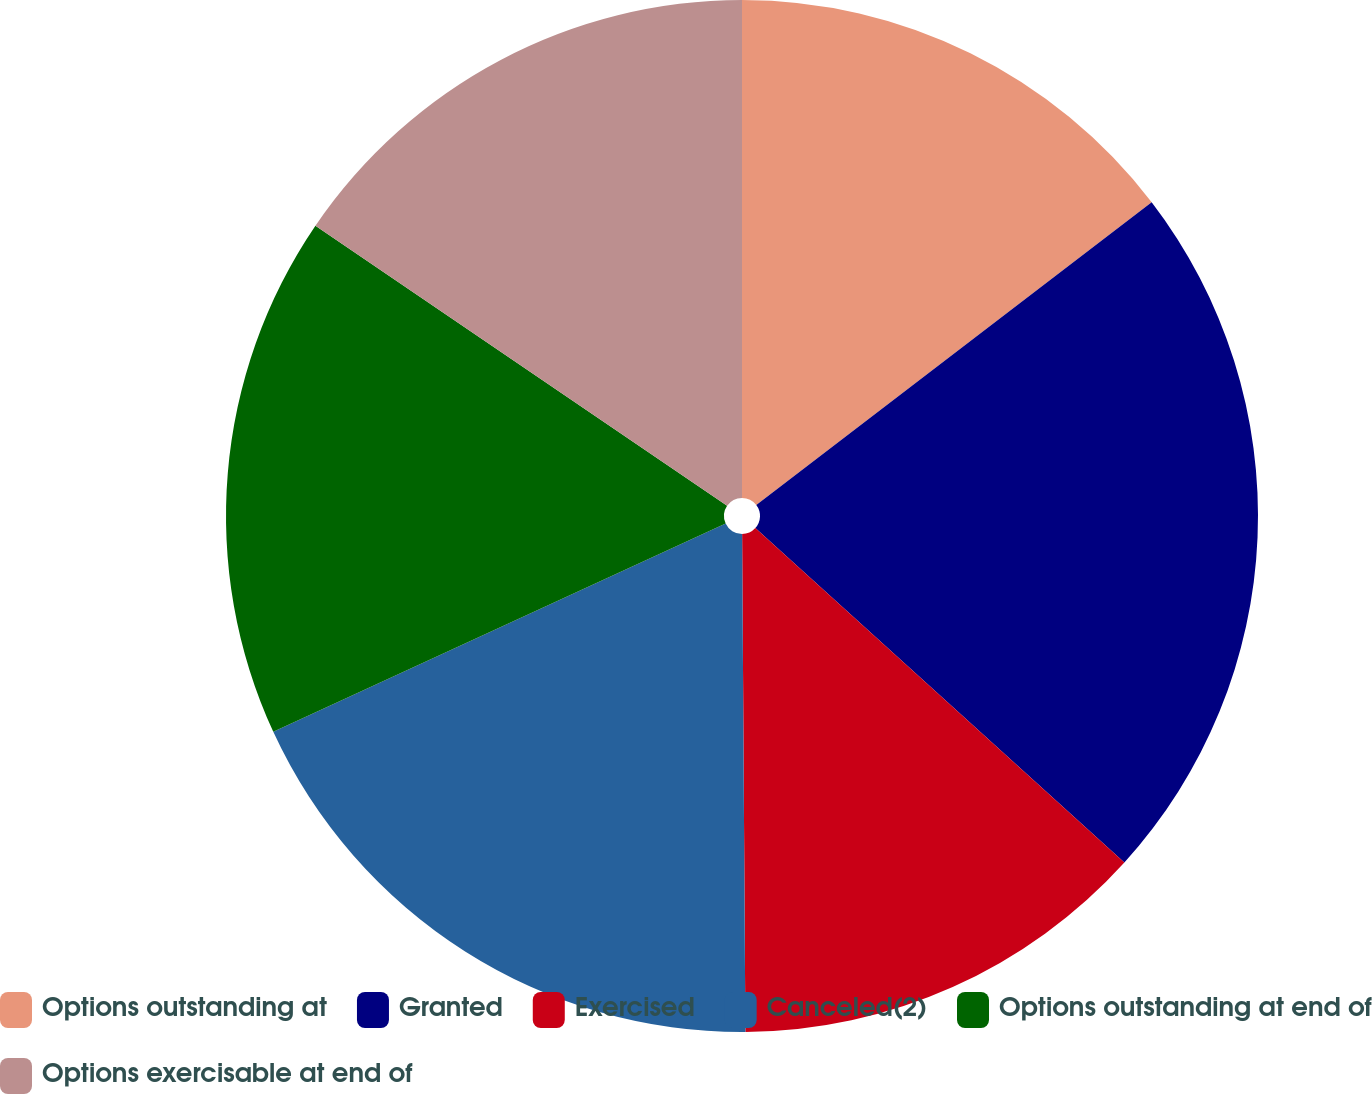Convert chart to OTSL. <chart><loc_0><loc_0><loc_500><loc_500><pie_chart><fcel>Options outstanding at<fcel>Granted<fcel>Exercised<fcel>Canceled(2)<fcel>Options outstanding at end of<fcel>Options exercisable at end of<nl><fcel>14.6%<fcel>22.12%<fcel>13.18%<fcel>18.24%<fcel>16.38%<fcel>15.49%<nl></chart> 